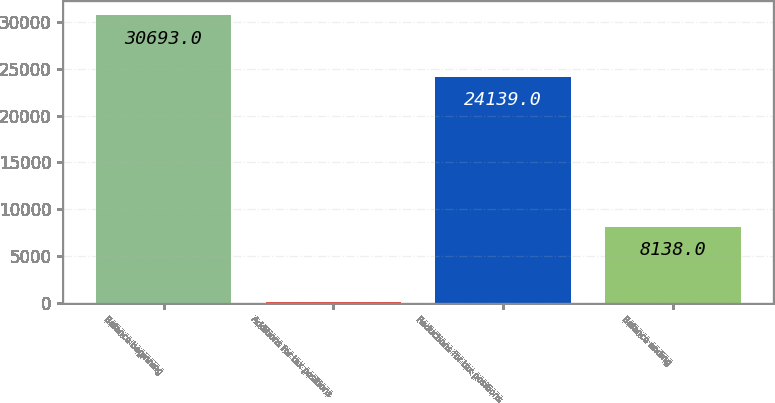<chart> <loc_0><loc_0><loc_500><loc_500><bar_chart><fcel>Balance beginning<fcel>Additions for tax positions<fcel>Reductions for tax positions<fcel>Balance ending<nl><fcel>30693<fcel>69<fcel>24139<fcel>8138<nl></chart> 